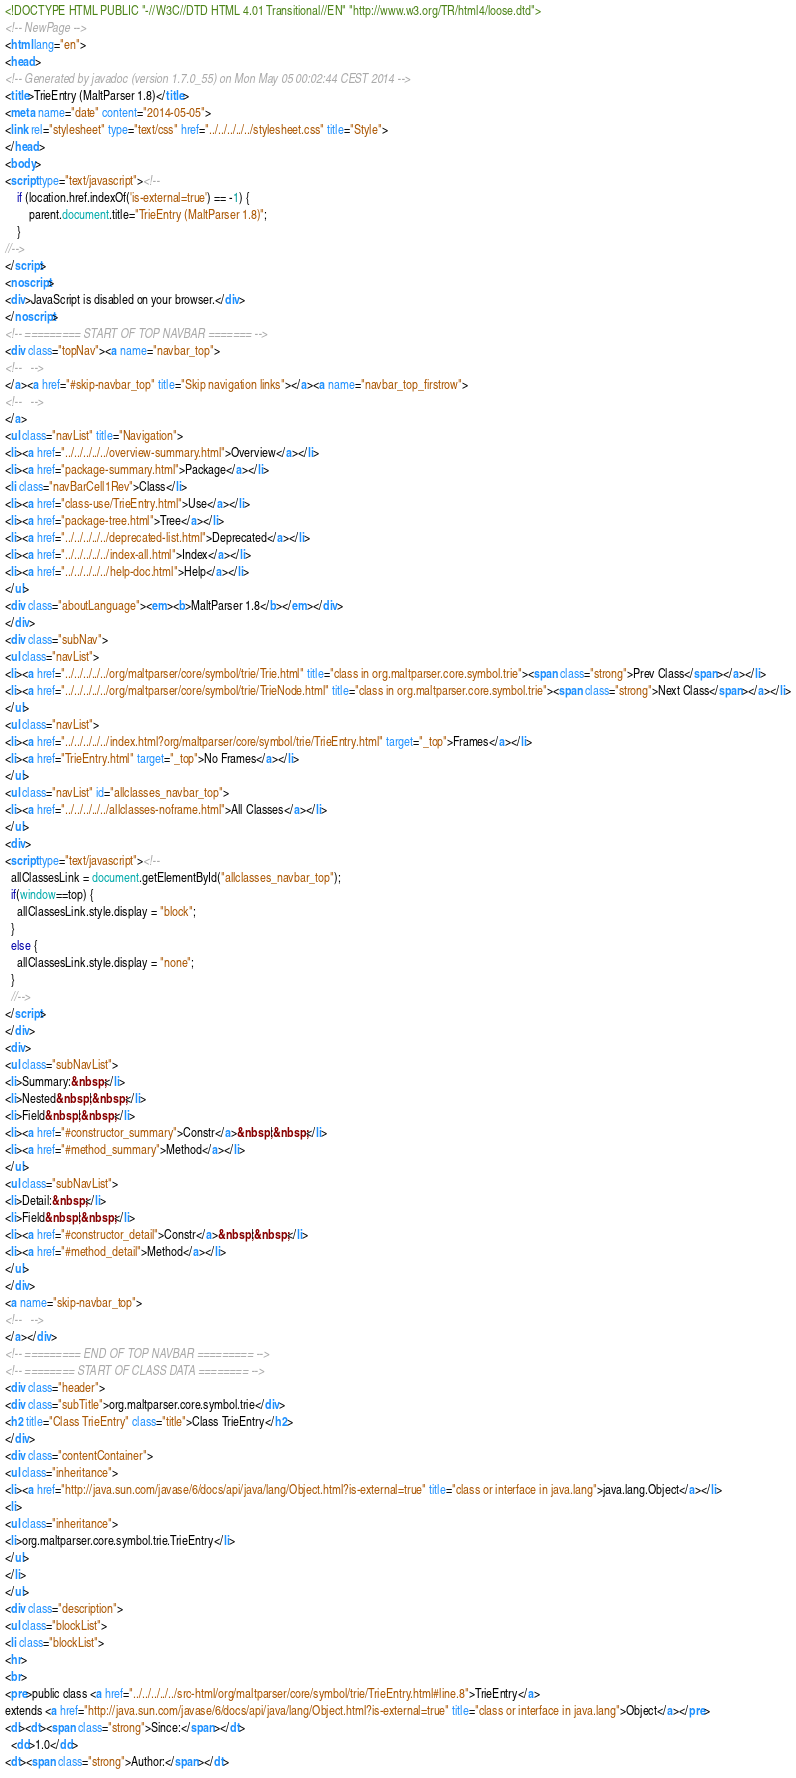<code> <loc_0><loc_0><loc_500><loc_500><_HTML_><!DOCTYPE HTML PUBLIC "-//W3C//DTD HTML 4.01 Transitional//EN" "http://www.w3.org/TR/html4/loose.dtd">
<!-- NewPage -->
<html lang="en">
<head>
<!-- Generated by javadoc (version 1.7.0_55) on Mon May 05 00:02:44 CEST 2014 -->
<title>TrieEntry (MaltParser 1.8)</title>
<meta name="date" content="2014-05-05">
<link rel="stylesheet" type="text/css" href="../../../../../stylesheet.css" title="Style">
</head>
<body>
<script type="text/javascript"><!--
    if (location.href.indexOf('is-external=true') == -1) {
        parent.document.title="TrieEntry (MaltParser 1.8)";
    }
//-->
</script>
<noscript>
<div>JavaScript is disabled on your browser.</div>
</noscript>
<!-- ========= START OF TOP NAVBAR ======= -->
<div class="topNav"><a name="navbar_top">
<!--   -->
</a><a href="#skip-navbar_top" title="Skip navigation links"></a><a name="navbar_top_firstrow">
<!--   -->
</a>
<ul class="navList" title="Navigation">
<li><a href="../../../../../overview-summary.html">Overview</a></li>
<li><a href="package-summary.html">Package</a></li>
<li class="navBarCell1Rev">Class</li>
<li><a href="class-use/TrieEntry.html">Use</a></li>
<li><a href="package-tree.html">Tree</a></li>
<li><a href="../../../../../deprecated-list.html">Deprecated</a></li>
<li><a href="../../../../../index-all.html">Index</a></li>
<li><a href="../../../../../help-doc.html">Help</a></li>
</ul>
<div class="aboutLanguage"><em><b>MaltParser 1.8</b></em></div>
</div>
<div class="subNav">
<ul class="navList">
<li><a href="../../../../../org/maltparser/core/symbol/trie/Trie.html" title="class in org.maltparser.core.symbol.trie"><span class="strong">Prev Class</span></a></li>
<li><a href="../../../../../org/maltparser/core/symbol/trie/TrieNode.html" title="class in org.maltparser.core.symbol.trie"><span class="strong">Next Class</span></a></li>
</ul>
<ul class="navList">
<li><a href="../../../../../index.html?org/maltparser/core/symbol/trie/TrieEntry.html" target="_top">Frames</a></li>
<li><a href="TrieEntry.html" target="_top">No Frames</a></li>
</ul>
<ul class="navList" id="allclasses_navbar_top">
<li><a href="../../../../../allclasses-noframe.html">All Classes</a></li>
</ul>
<div>
<script type="text/javascript"><!--
  allClassesLink = document.getElementById("allclasses_navbar_top");
  if(window==top) {
    allClassesLink.style.display = "block";
  }
  else {
    allClassesLink.style.display = "none";
  }
  //-->
</script>
</div>
<div>
<ul class="subNavList">
<li>Summary:&nbsp;</li>
<li>Nested&nbsp;|&nbsp;</li>
<li>Field&nbsp;|&nbsp;</li>
<li><a href="#constructor_summary">Constr</a>&nbsp;|&nbsp;</li>
<li><a href="#method_summary">Method</a></li>
</ul>
<ul class="subNavList">
<li>Detail:&nbsp;</li>
<li>Field&nbsp;|&nbsp;</li>
<li><a href="#constructor_detail">Constr</a>&nbsp;|&nbsp;</li>
<li><a href="#method_detail">Method</a></li>
</ul>
</div>
<a name="skip-navbar_top">
<!--   -->
</a></div>
<!-- ========= END OF TOP NAVBAR ========= -->
<!-- ======== START OF CLASS DATA ======== -->
<div class="header">
<div class="subTitle">org.maltparser.core.symbol.trie</div>
<h2 title="Class TrieEntry" class="title">Class TrieEntry</h2>
</div>
<div class="contentContainer">
<ul class="inheritance">
<li><a href="http://java.sun.com/javase/6/docs/api/java/lang/Object.html?is-external=true" title="class or interface in java.lang">java.lang.Object</a></li>
<li>
<ul class="inheritance">
<li>org.maltparser.core.symbol.trie.TrieEntry</li>
</ul>
</li>
</ul>
<div class="description">
<ul class="blockList">
<li class="blockList">
<hr>
<br>
<pre>public class <a href="../../../../../src-html/org/maltparser/core/symbol/trie/TrieEntry.html#line.8">TrieEntry</a>
extends <a href="http://java.sun.com/javase/6/docs/api/java/lang/Object.html?is-external=true" title="class or interface in java.lang">Object</a></pre>
<dl><dt><span class="strong">Since:</span></dt>
  <dd>1.0</dd>
<dt><span class="strong">Author:</span></dt></code> 